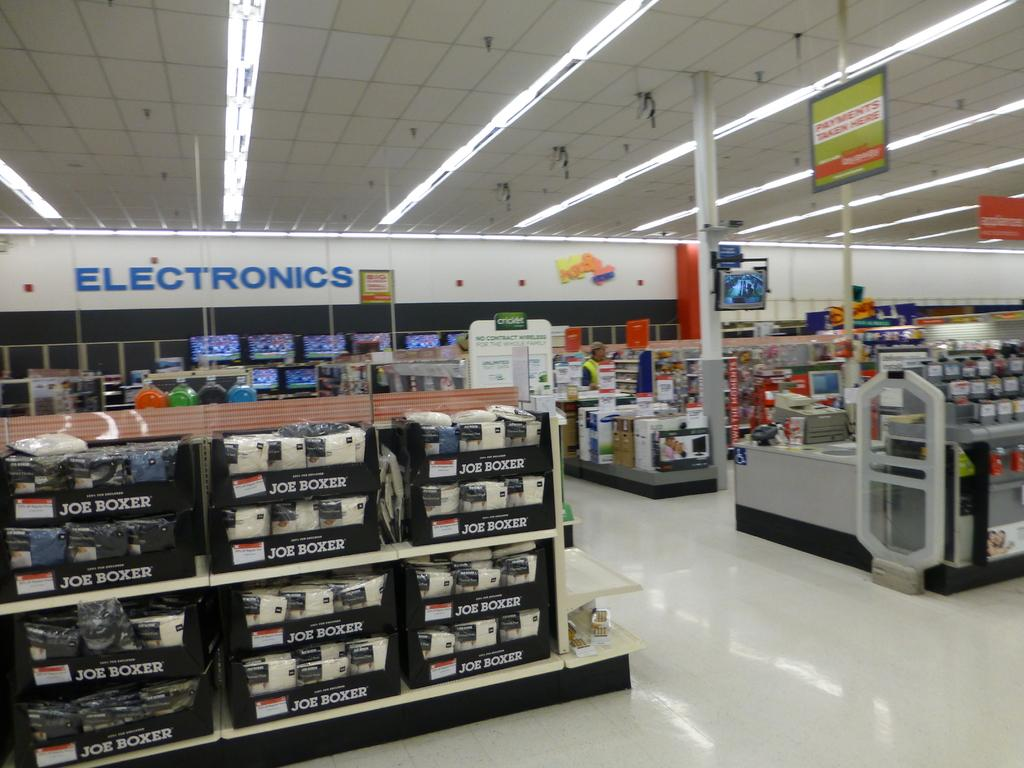<image>
Summarize the visual content of the image. A shelf of Joe Boxer sheets in front of the electronics department of a retail store. 